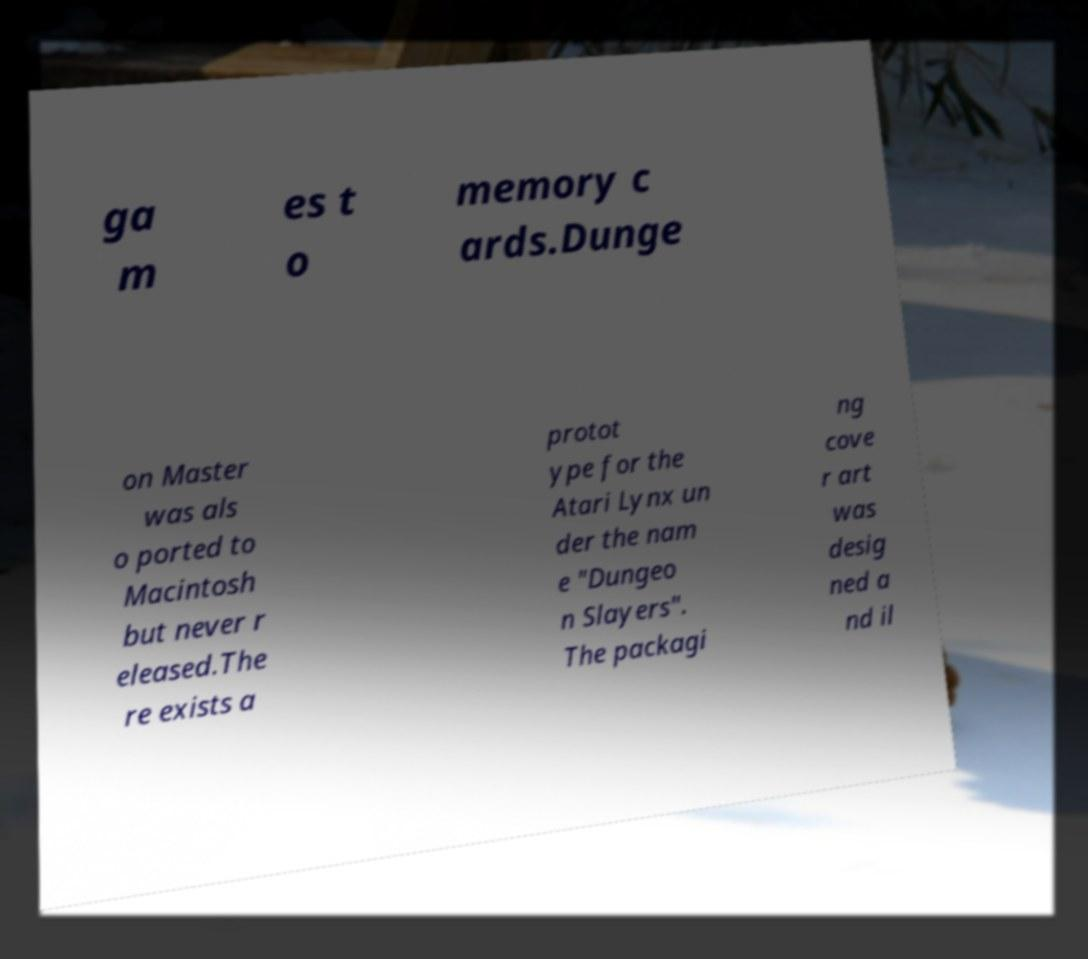Could you extract and type out the text from this image? ga m es t o memory c ards.Dunge on Master was als o ported to Macintosh but never r eleased.The re exists a protot ype for the Atari Lynx un der the nam e "Dungeo n Slayers". The packagi ng cove r art was desig ned a nd il 